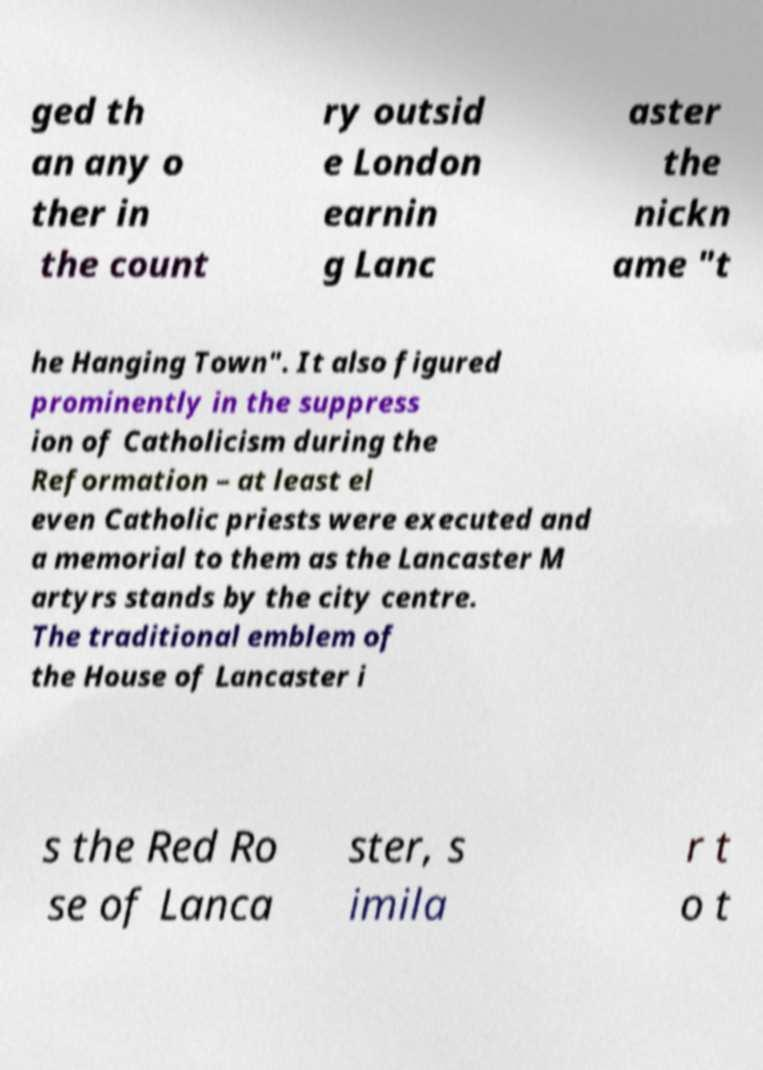Can you read and provide the text displayed in the image?This photo seems to have some interesting text. Can you extract and type it out for me? ged th an any o ther in the count ry outsid e London earnin g Lanc aster the nickn ame "t he Hanging Town". It also figured prominently in the suppress ion of Catholicism during the Reformation – at least el even Catholic priests were executed and a memorial to them as the Lancaster M artyrs stands by the city centre. The traditional emblem of the House of Lancaster i s the Red Ro se of Lanca ster, s imila r t o t 